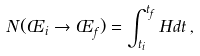Convert formula to latex. <formula><loc_0><loc_0><loc_500><loc_500>N ( \phi _ { i } \rightarrow \phi _ { f } ) = \int _ { t _ { i } } ^ { t _ { f } } H d t \, ,</formula> 